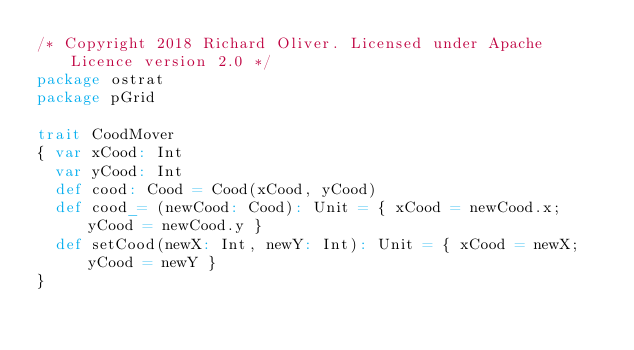Convert code to text. <code><loc_0><loc_0><loc_500><loc_500><_Scala_>/* Copyright 2018 Richard Oliver. Licensed under Apache Licence version 2.0 */
package ostrat
package pGrid

trait CoodMover
{ var xCood: Int
  var yCood: Int
  def cood: Cood = Cood(xCood, yCood) 
  def cood_= (newCood: Cood): Unit = { xCood = newCood.x; yCood = newCood.y }
  def setCood(newX: Int, newY: Int): Unit = { xCood = newX; yCood = newY }
}</code> 